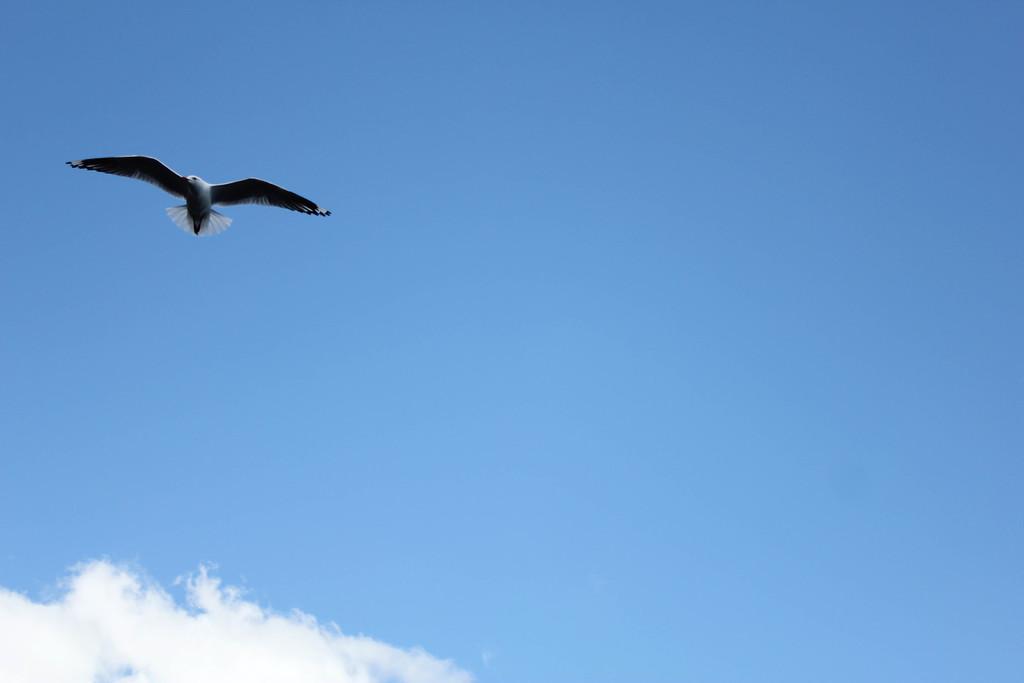Could you give a brief overview of what you see in this image? In this image we can see a bird is flying in the air. In the background there is sky with clouds. 